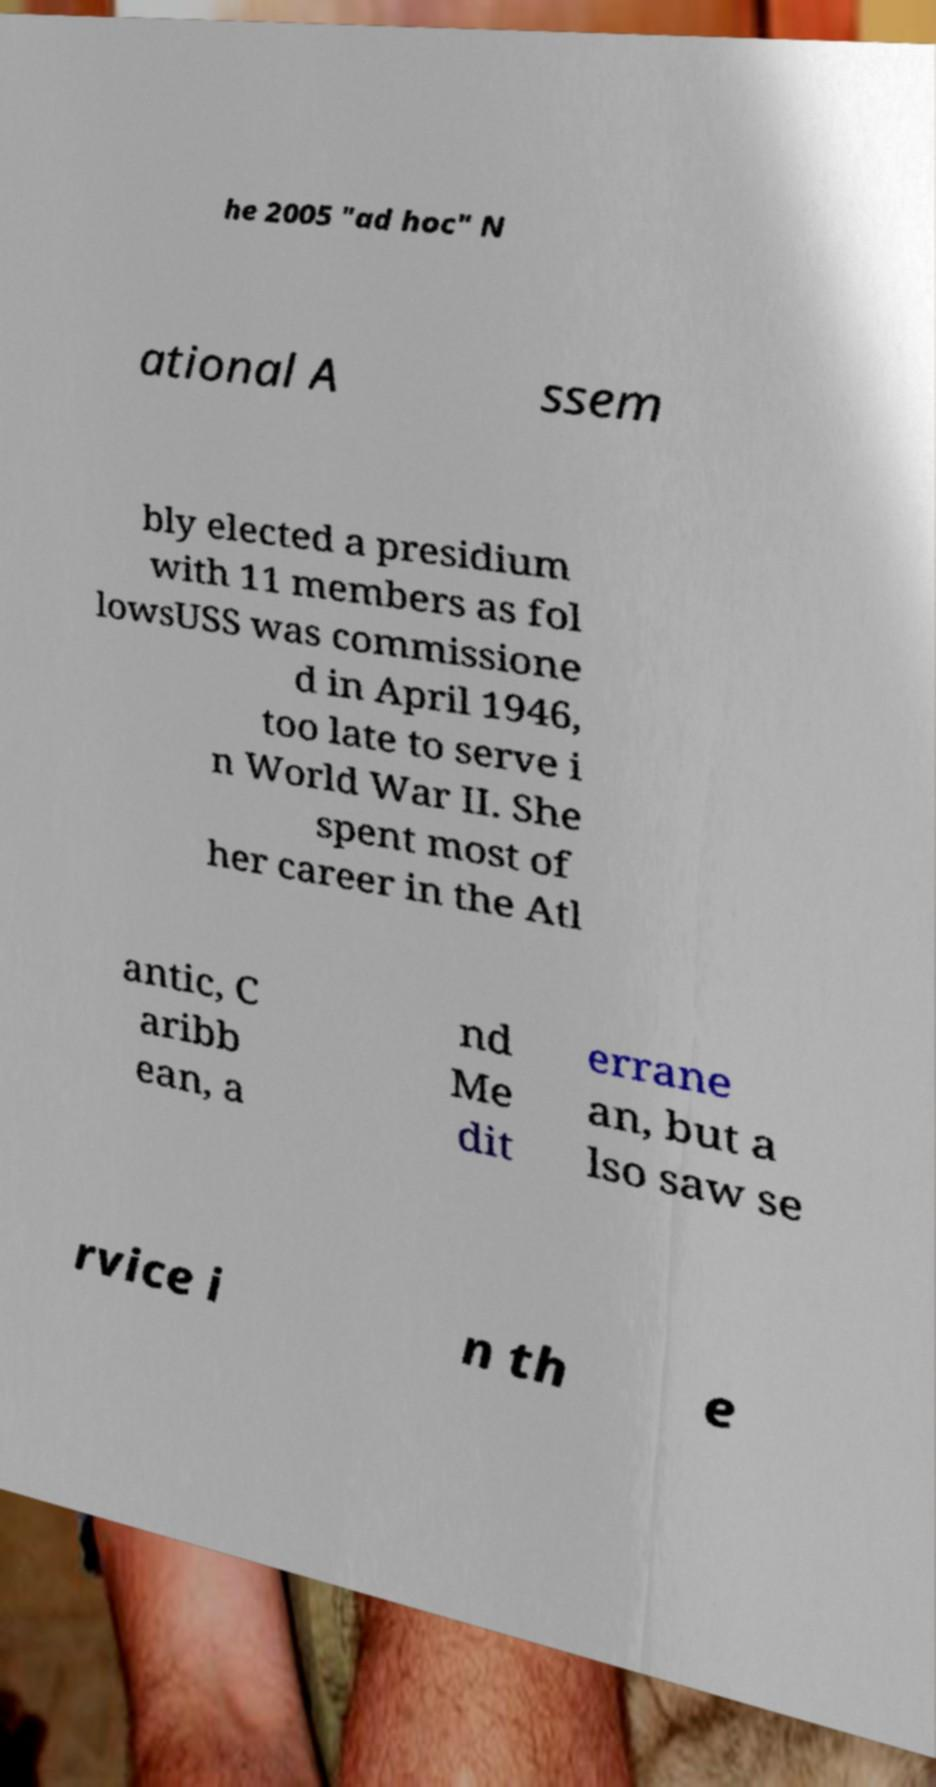Could you assist in decoding the text presented in this image and type it out clearly? he 2005 "ad hoc" N ational A ssem bly elected a presidium with 11 members as fol lowsUSS was commissione d in April 1946, too late to serve i n World War II. She spent most of her career in the Atl antic, C aribb ean, a nd Me dit errane an, but a lso saw se rvice i n th e 